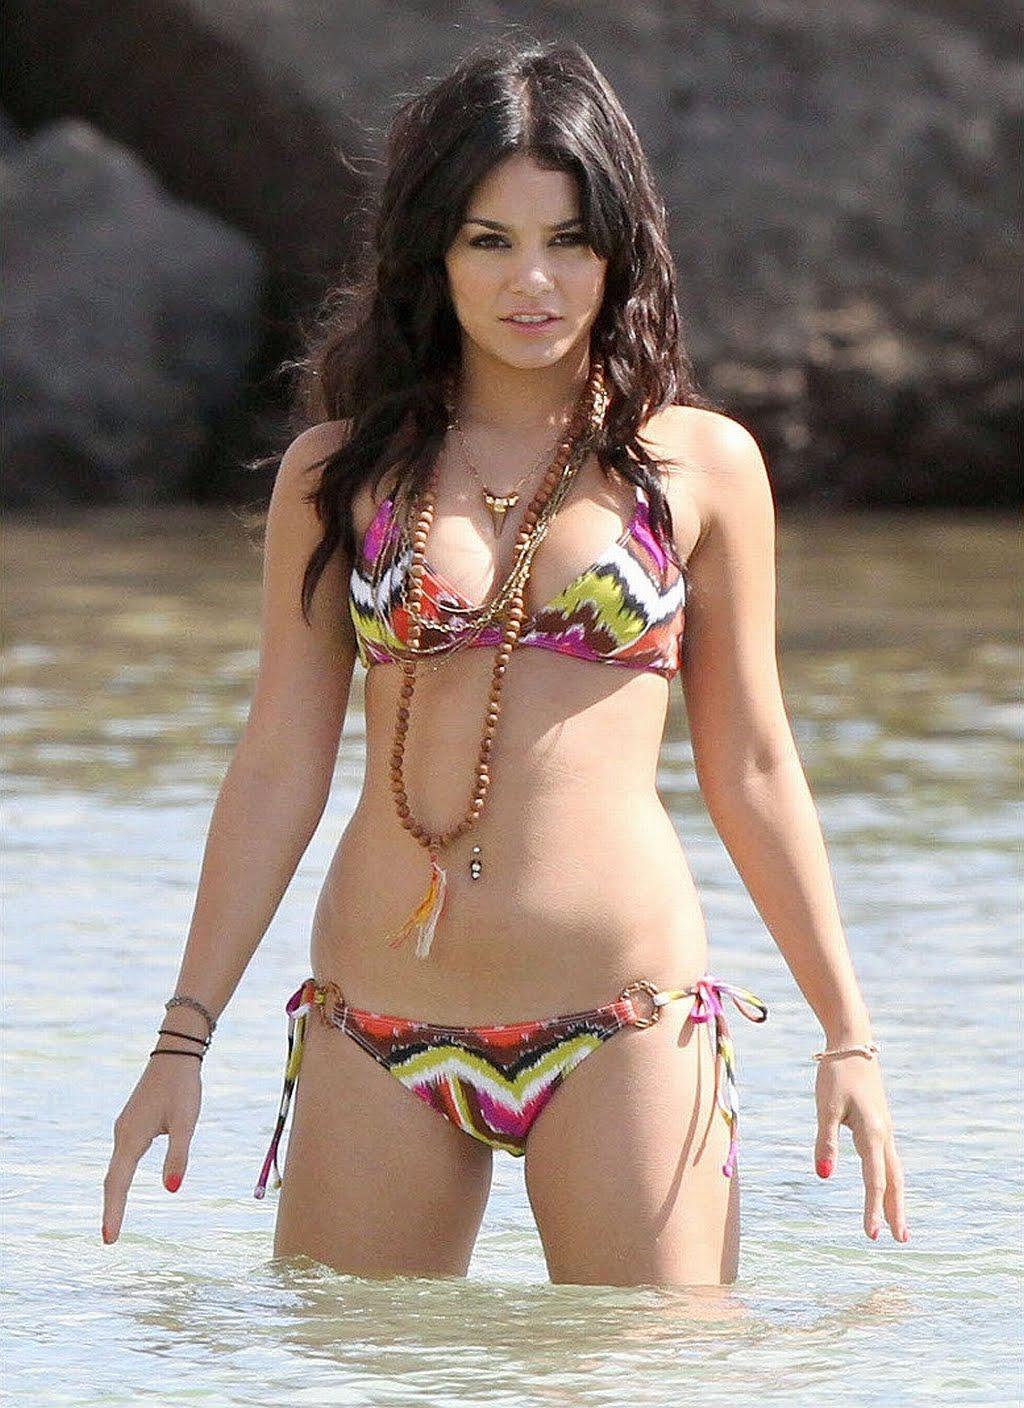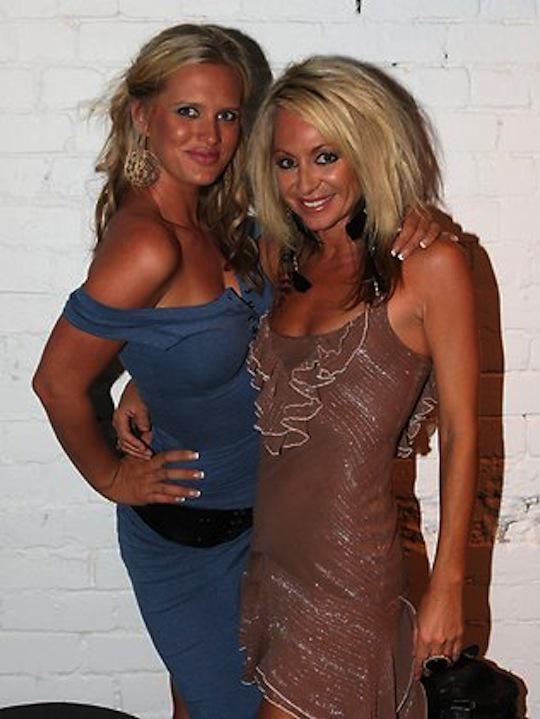The first image is the image on the left, the second image is the image on the right. For the images displayed, is the sentence "Each of the images contains exactly one model." factually correct? Answer yes or no. No. 